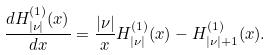Convert formula to latex. <formula><loc_0><loc_0><loc_500><loc_500>\frac { d H ^ { ( 1 ) } _ { | \nu | } ( x ) } { d x } = \frac { | \nu | } { x } H ^ { ( 1 ) } _ { | \nu | } ( x ) - H ^ { ( 1 ) } _ { | \nu | + 1 } ( x ) .</formula> 